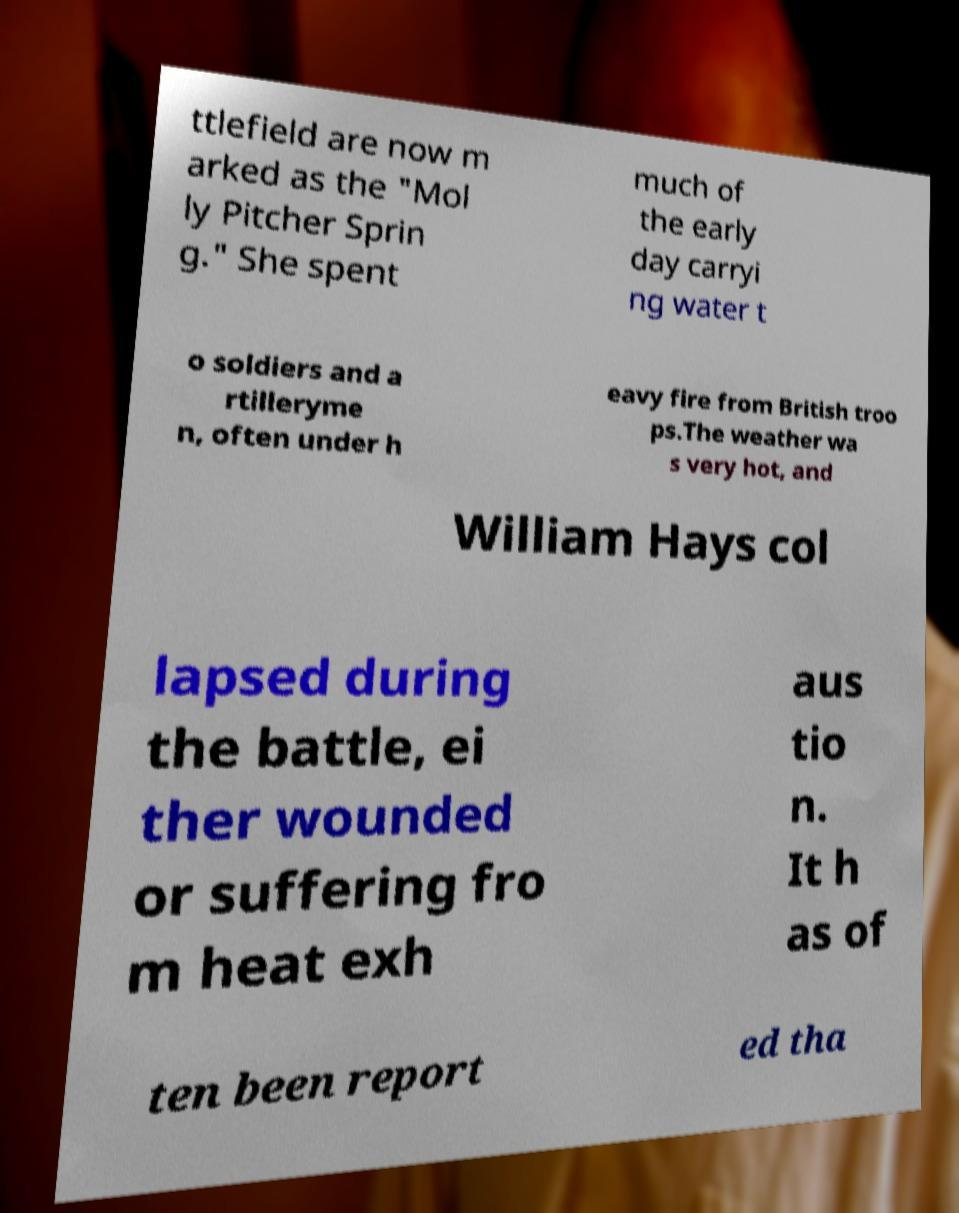Could you assist in decoding the text presented in this image and type it out clearly? ttlefield are now m arked as the "Mol ly Pitcher Sprin g." She spent much of the early day carryi ng water t o soldiers and a rtilleryme n, often under h eavy fire from British troo ps.The weather wa s very hot, and William Hays col lapsed during the battle, ei ther wounded or suffering fro m heat exh aus tio n. It h as of ten been report ed tha 